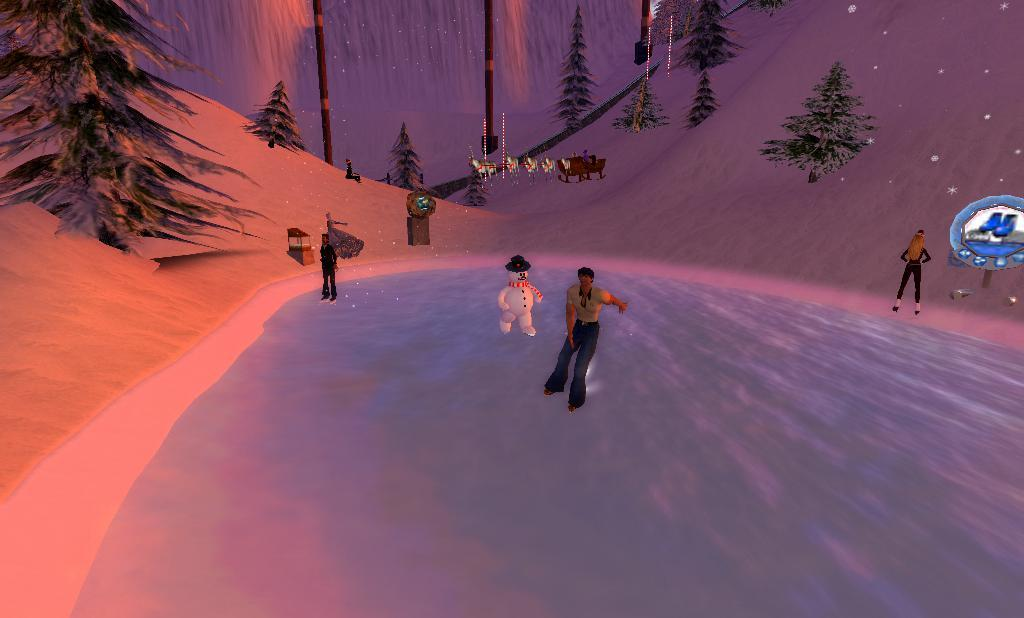What type of characters are present in the image? There are animated people and animals in the image. What is the setting of the image? The image features a snowy environment with trees, wooden poles, mountains, and a snowman. What is the weather like in the image? The weather is snowy, as indicated by the presence of snow. What other animated objects can be seen in the image? There are other animated objects in the image, such as the snowman and wooden poles. What is the topic of the discussion taking place between the animated characters in the image? There is no discussion taking place between the animated characters in the image. What type of box can be seen in the image? There is no box present in the image. 